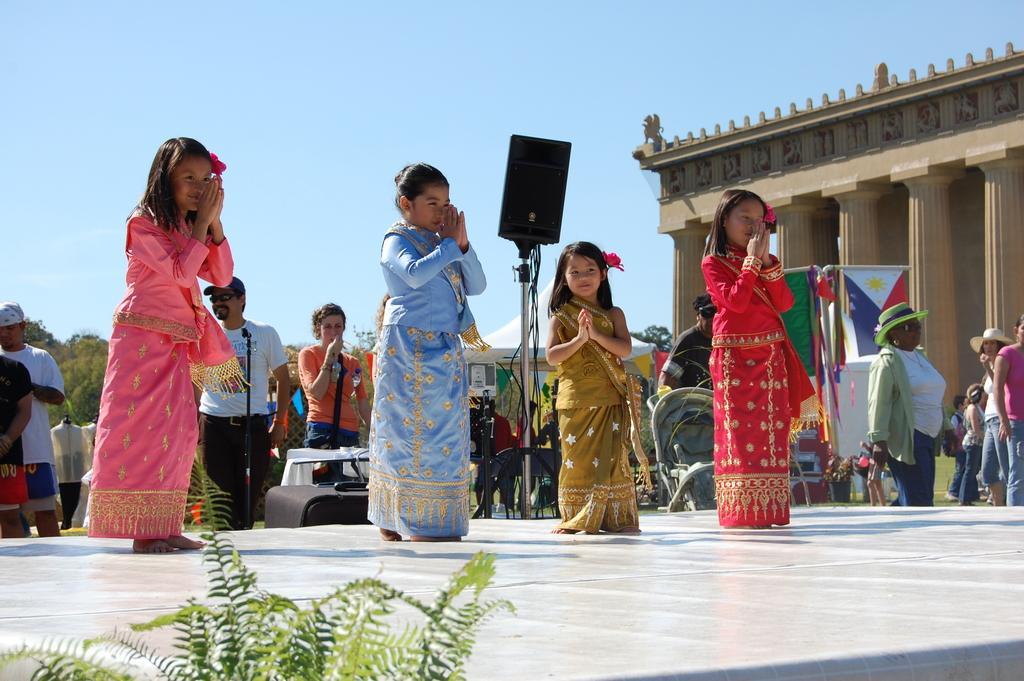Could you give a brief overview of what you see in this image? In this image in the center there are some children who are wearing costumes, and they are on stage. At the bottom there is a plant, in the background there are a group of people and some flags, tent, speaker, cameras, table, wires, grass and objects. On the right side of the image there is a building and some pillars, and in the background there are trees. At the top there is sky. 